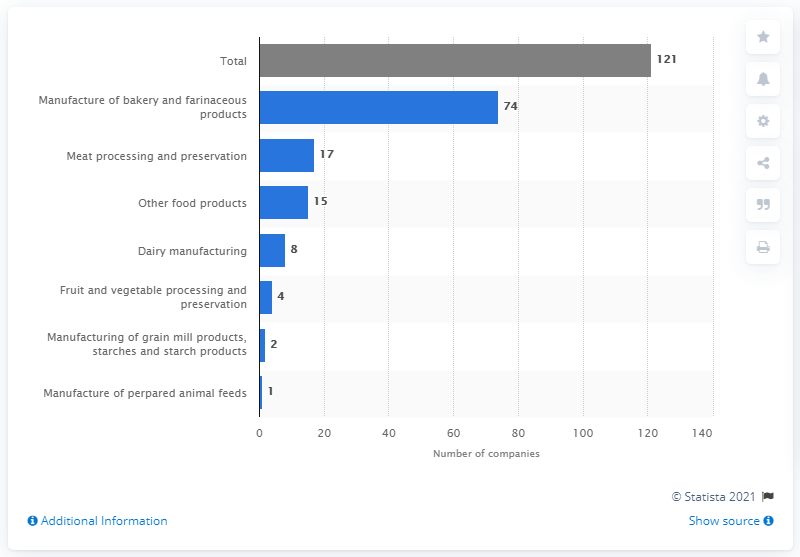Specify some key components in this picture. In 2018, 121 companies were involved in the production of food in Luxembourg. Seventeen companies in Luxembourg produce meat products. 